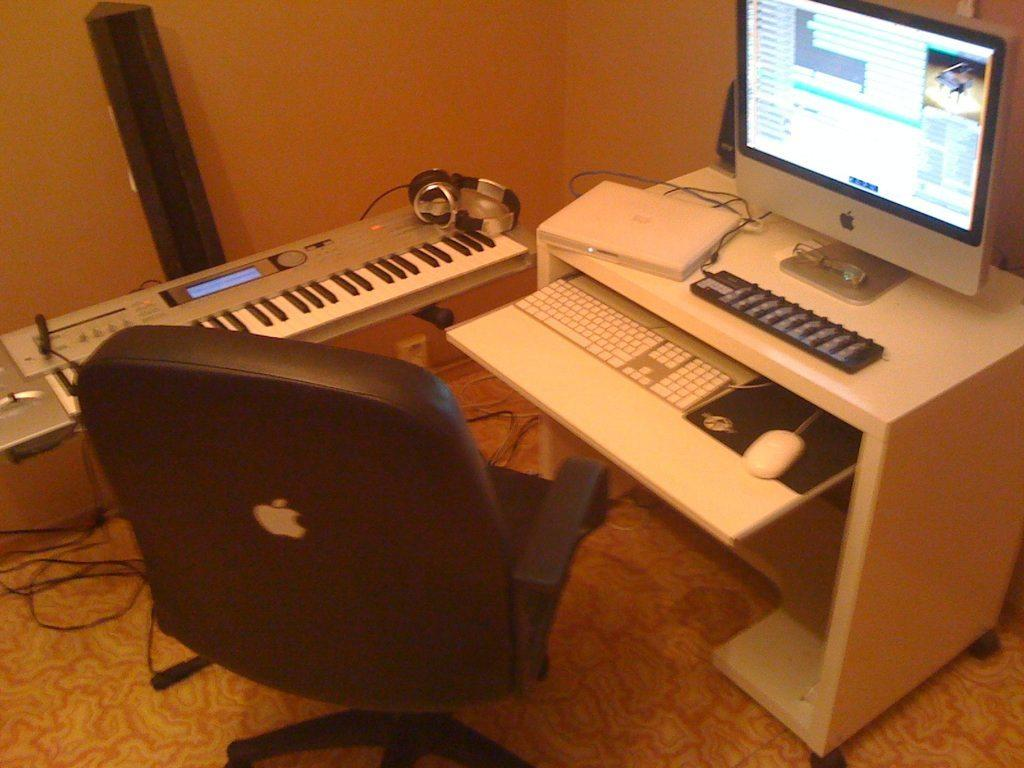What can be seen in the image related to technology? There is a laptop on the table in the image. What type of furniture is in front of the table? There is a chair in front of the table. What musical instrument is visible in the background? There is a piano in the background. What device is present in the background for audio communication? There is a headset in the background. How many frogs are sitting on the laptop in the image? There are no frogs present in the image; only a laptop, chair, piano, and headset can be seen. 